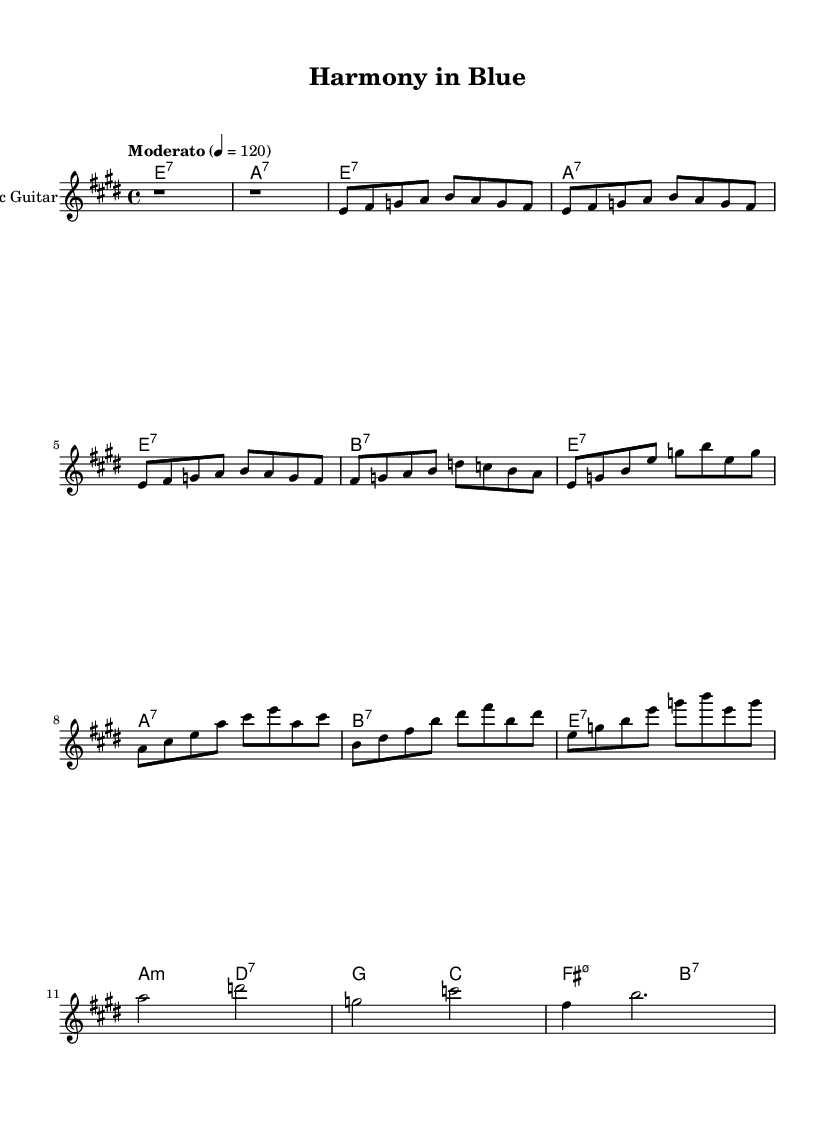What is the key signature of this music? The key signature is E major, which consists of four sharps (F#, C#, G#, and D#). This is indicated at the beginning of the staff.
Answer: E major What is the time signature of this music? The time signature is 4/4, as shown at the beginning of the score. This means there are four beats in a measure, and each quarter note receives one beat.
Answer: 4/4 What is the tempo marking for this music? The tempo marking is "Moderato" at a speed of 120 beats per minute, which indicates a moderate pace for the performance of the piece.
Answer: Moderato How many measures are in the first verse section? The first verse consists of 4 measures (indicated by the division of the notes grouped together).
Answer: 4 What type of guitar is used in this piece? The notation specifies "Electric Guitar" as the instrument, which is typically used in electric blues music, allowing for amplified sound and distortion effects.
Answer: Electric Guitar Which chord appears most frequently in the chorus section? The chord E7 appears frequently in the chorus, where it is played at the beginning and within multiple measures. This emphasizes the tonal center of the piece.
Answer: E7 How does the bridge section contribute to the song structure? The bridge introduces a different harmonic sequence and contrasts with the verse and chorus, helping to create tension and prepare for a return to the themes of the verses and chorus.
Answer: Contrast 